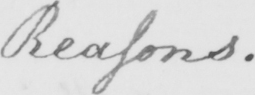What does this handwritten line say? Reasons . 